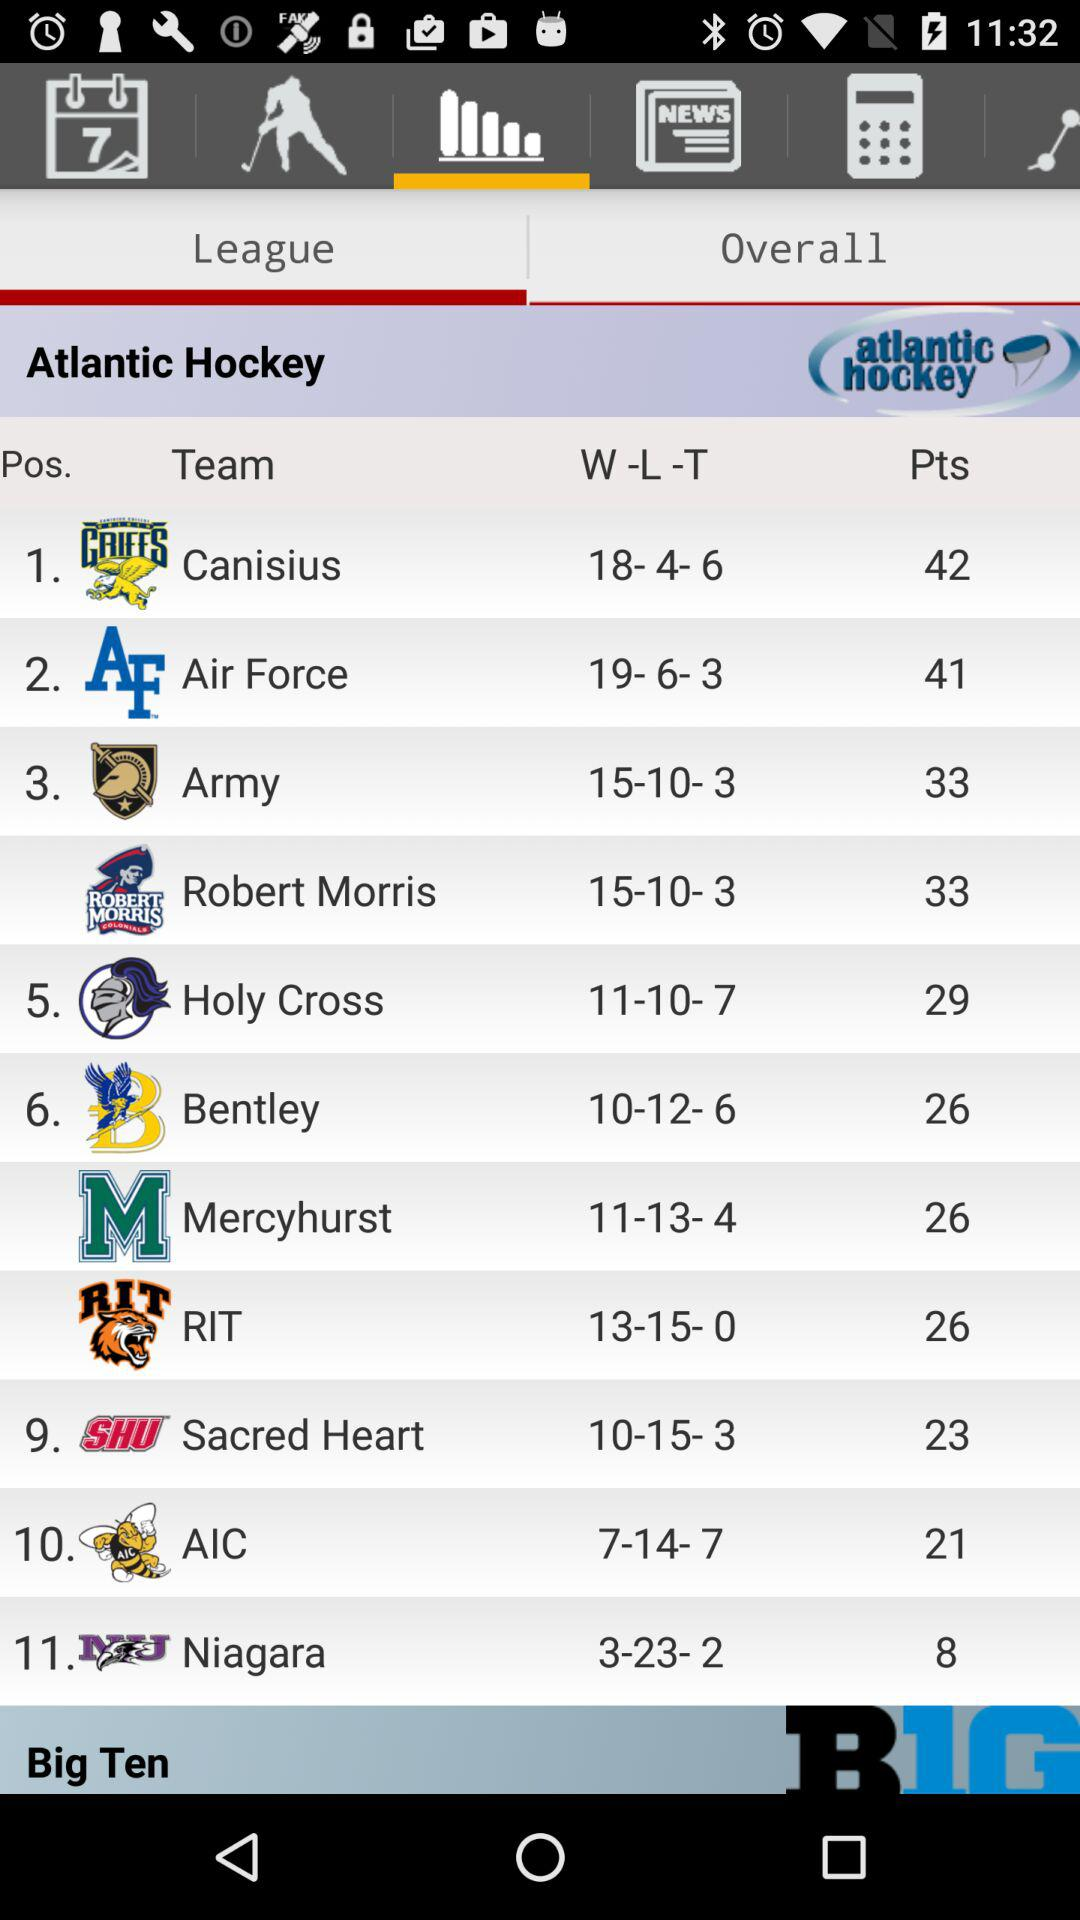Which tab is selected? The selected tab is "League". 